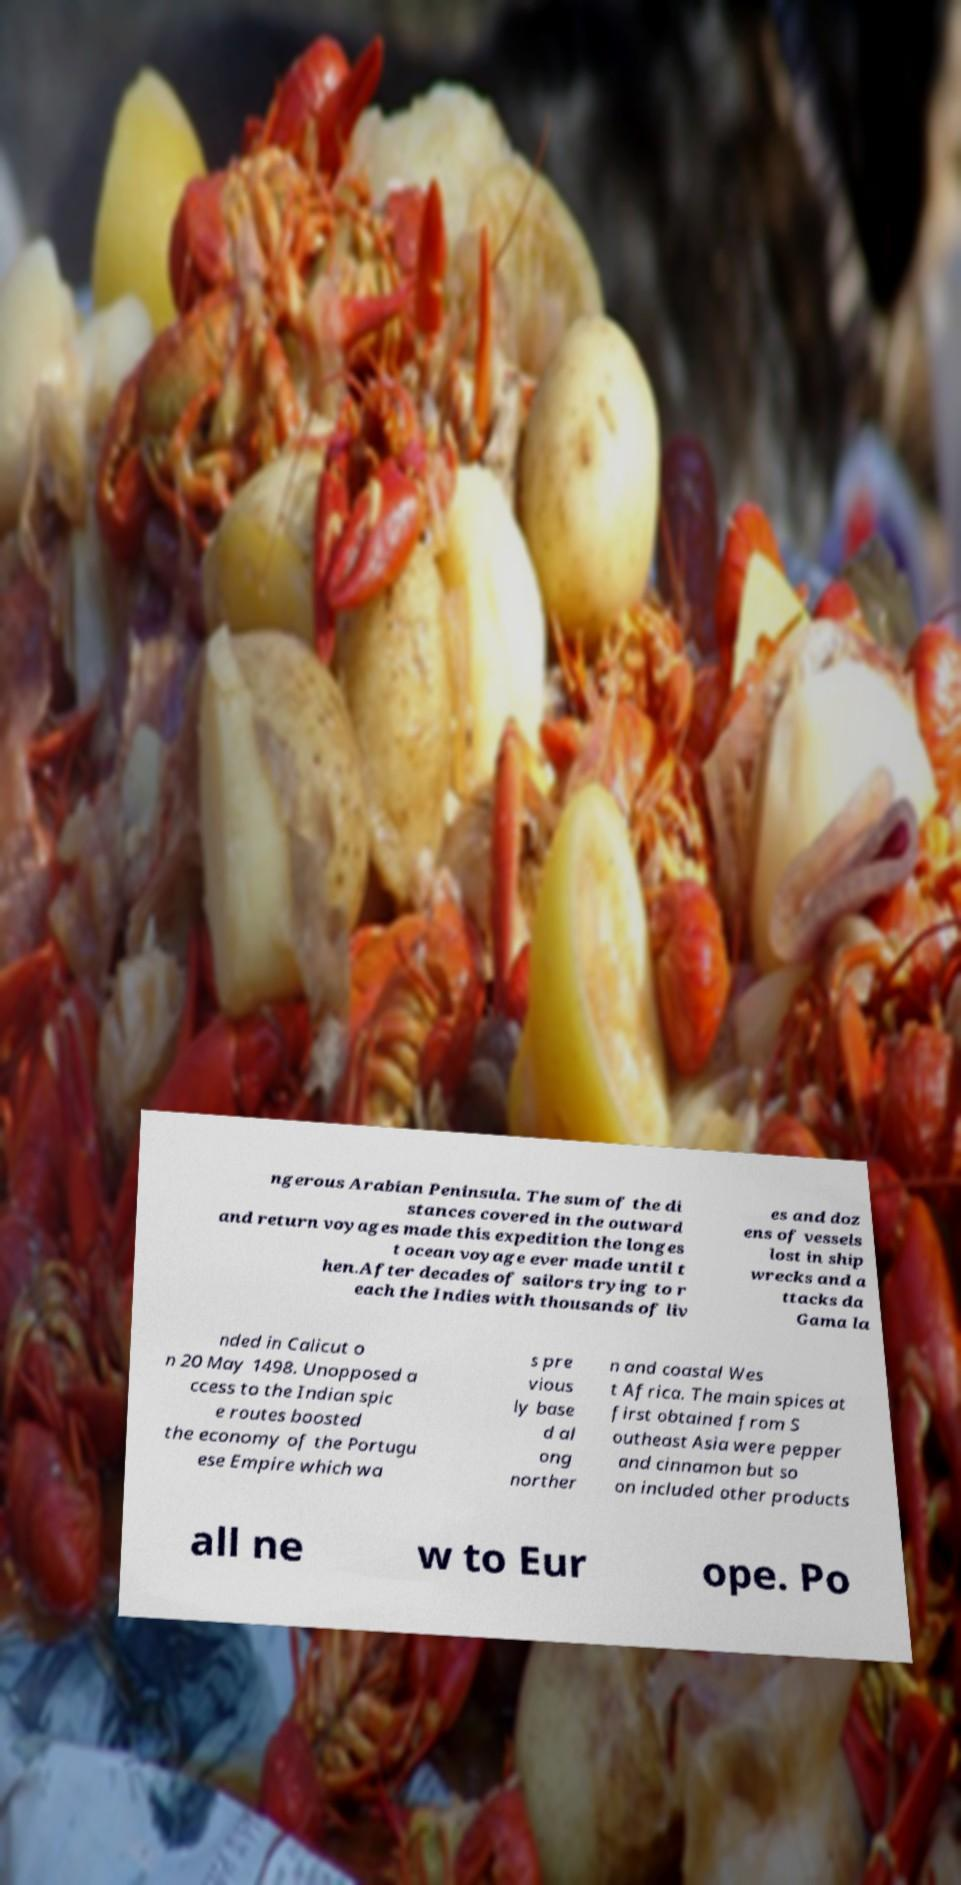There's text embedded in this image that I need extracted. Can you transcribe it verbatim? ngerous Arabian Peninsula. The sum of the di stances covered in the outward and return voyages made this expedition the longes t ocean voyage ever made until t hen.After decades of sailors trying to r each the Indies with thousands of liv es and doz ens of vessels lost in ship wrecks and a ttacks da Gama la nded in Calicut o n 20 May 1498. Unopposed a ccess to the Indian spic e routes boosted the economy of the Portugu ese Empire which wa s pre vious ly base d al ong norther n and coastal Wes t Africa. The main spices at first obtained from S outheast Asia were pepper and cinnamon but so on included other products all ne w to Eur ope. Po 